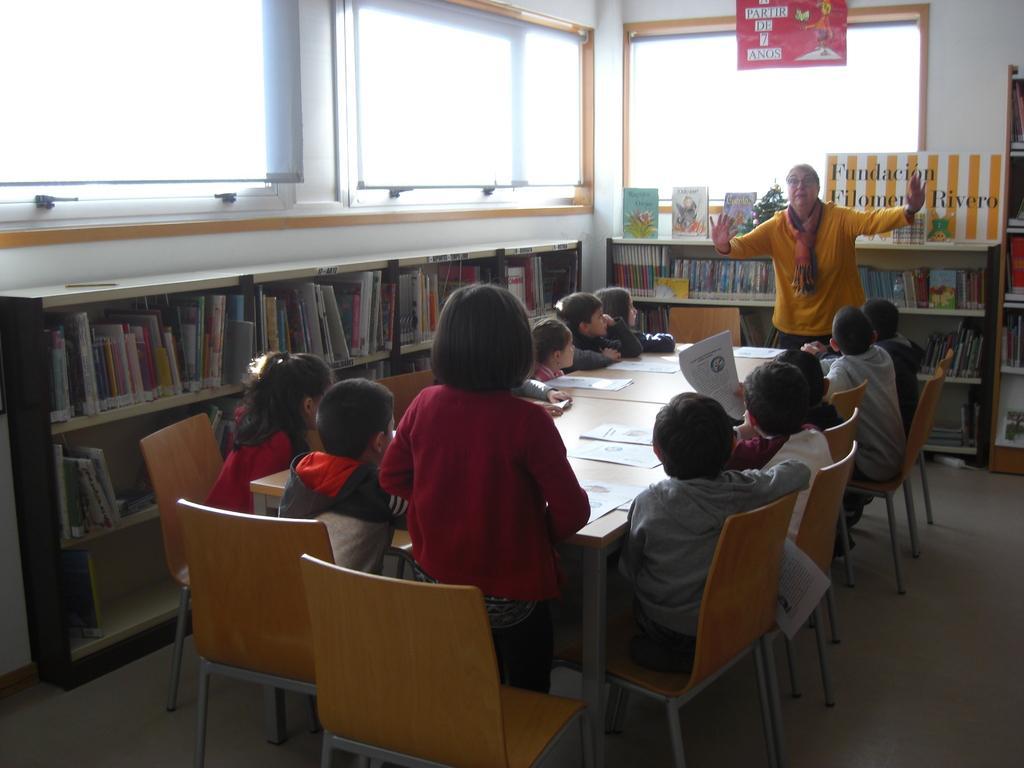Could you give a brief overview of what you see in this image? This picture describes about group of people who are all seated on the chair, two people are standing, in front of them we can see papers on the table, and also we can find some books in the book shelf and a plant. 